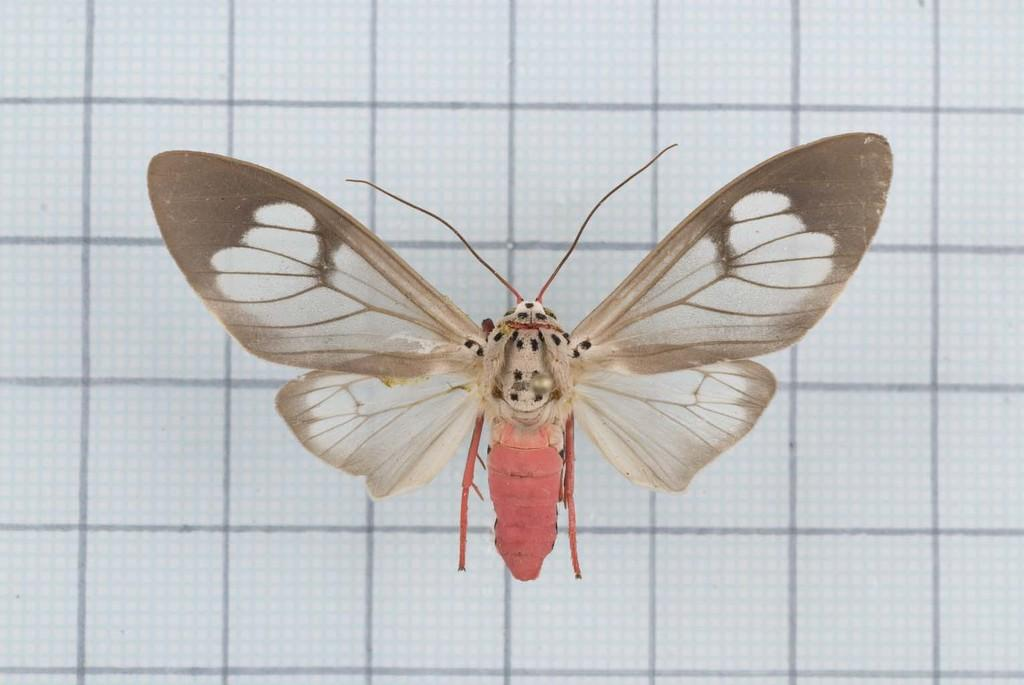What is located in the foreground of the image? There is a fly in the foreground of the image. What type of surface is the fly on? The fly is on a white surface. Are there any markings or patterns on the white surface? Yes, there are lines on the white surface. What letters can be seen on the fly's wings in the image? There are no letters visible on the fly's wings in the image. What type of spark can be seen coming from the fly's body in the image? There is no spark present on the fly's body in the image. 